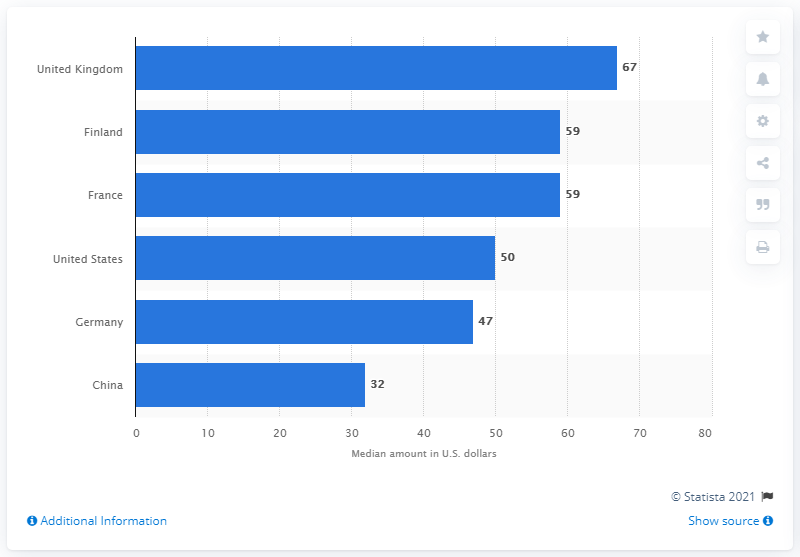Mention a couple of crucial points in this snapshot. According to the survey, the median amount that smartphone owners in the United States would be willing to pay extra for their next 5G-enabled smartphone is $50. 